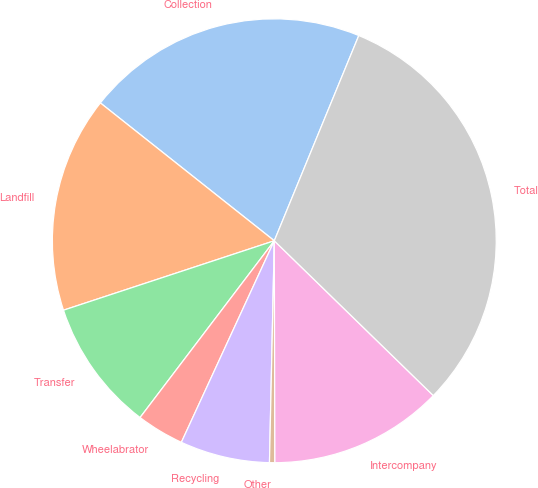Convert chart. <chart><loc_0><loc_0><loc_500><loc_500><pie_chart><fcel>Collection<fcel>Landfill<fcel>Transfer<fcel>Wheelabrator<fcel>Recycling<fcel>Other<fcel>Intercompany<fcel>Total<nl><fcel>20.55%<fcel>15.73%<fcel>9.6%<fcel>3.46%<fcel>6.53%<fcel>0.39%<fcel>12.67%<fcel>31.07%<nl></chart> 